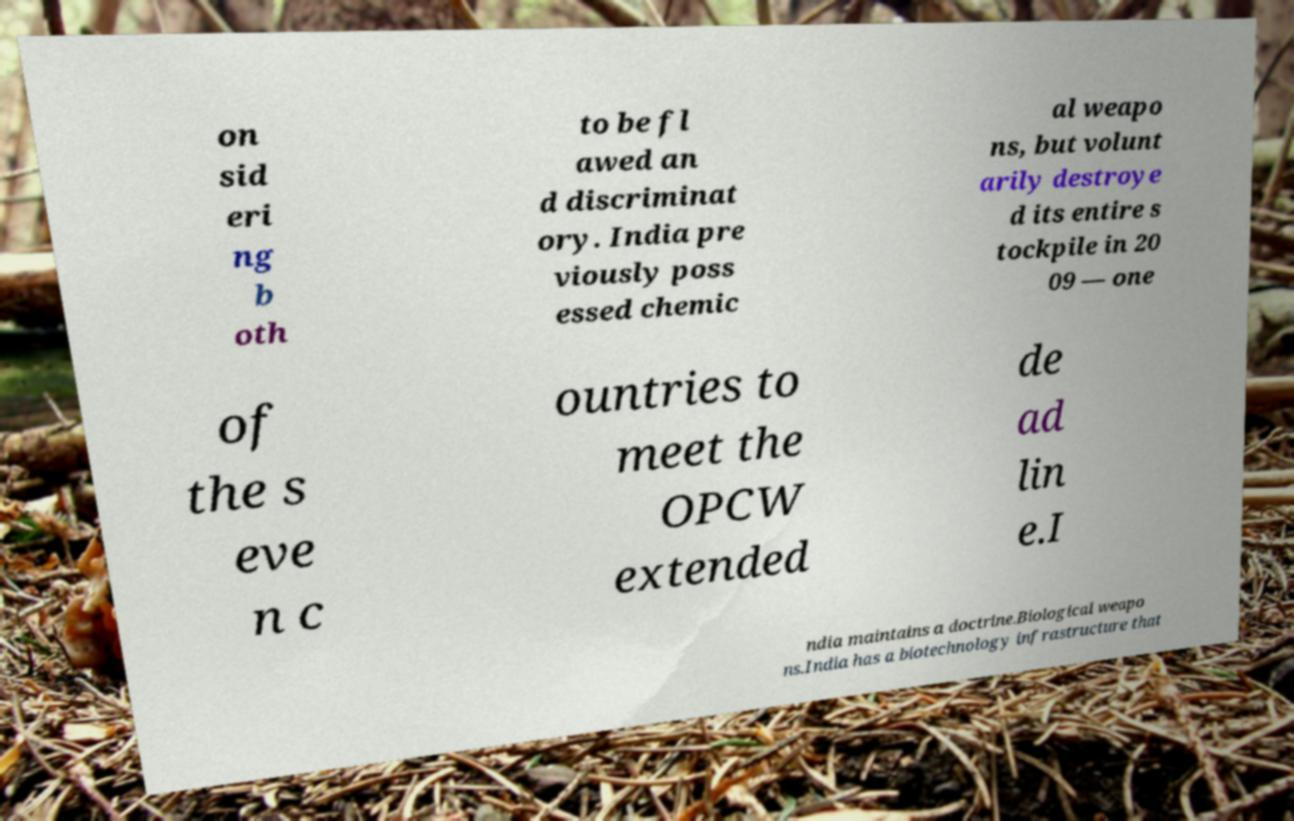Please read and relay the text visible in this image. What does it say? on sid eri ng b oth to be fl awed an d discriminat ory. India pre viously poss essed chemic al weapo ns, but volunt arily destroye d its entire s tockpile in 20 09 — one of the s eve n c ountries to meet the OPCW extended de ad lin e.I ndia maintains a doctrine.Biological weapo ns.India has a biotechnology infrastructure that 